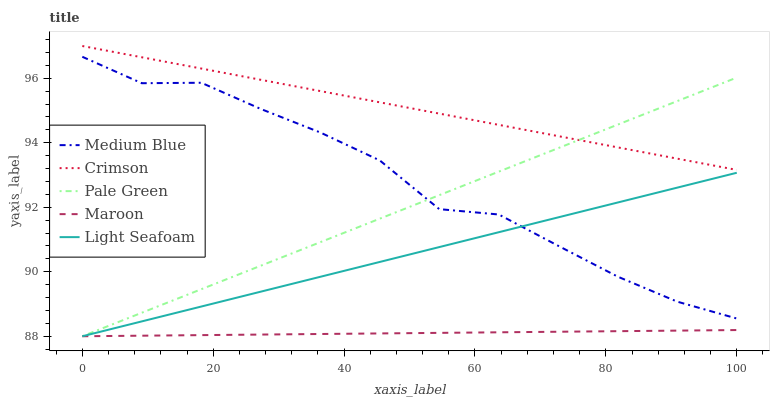Does Maroon have the minimum area under the curve?
Answer yes or no. Yes. Does Crimson have the maximum area under the curve?
Answer yes or no. Yes. Does Light Seafoam have the minimum area under the curve?
Answer yes or no. No. Does Light Seafoam have the maximum area under the curve?
Answer yes or no. No. Is Pale Green the smoothest?
Answer yes or no. Yes. Is Medium Blue the roughest?
Answer yes or no. Yes. Is Light Seafoam the smoothest?
Answer yes or no. No. Is Light Seafoam the roughest?
Answer yes or no. No. Does Medium Blue have the lowest value?
Answer yes or no. No. Does Crimson have the highest value?
Answer yes or no. Yes. Does Light Seafoam have the highest value?
Answer yes or no. No. Is Maroon less than Medium Blue?
Answer yes or no. Yes. Is Crimson greater than Medium Blue?
Answer yes or no. Yes. Does Maroon intersect Medium Blue?
Answer yes or no. No. 